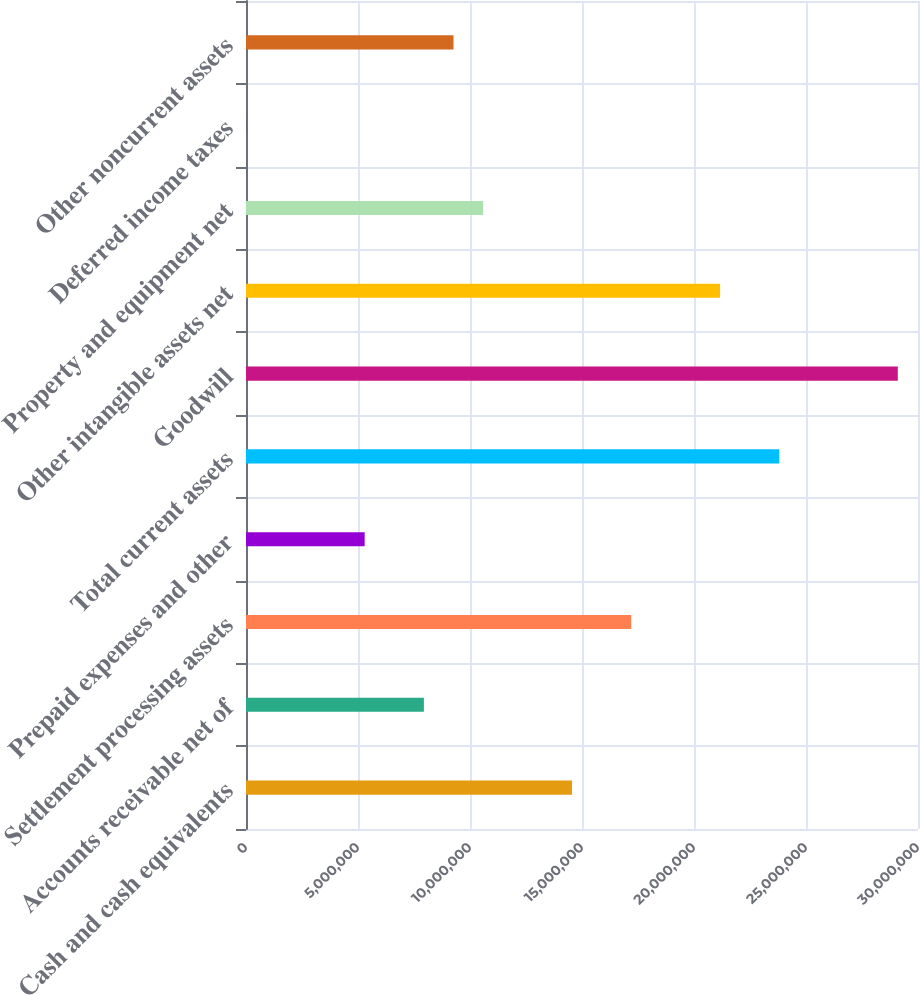Convert chart to OTSL. <chart><loc_0><loc_0><loc_500><loc_500><bar_chart><fcel>Cash and cash equivalents<fcel>Accounts receivable net of<fcel>Settlement processing assets<fcel>Prepaid expenses and other<fcel>Total current assets<fcel>Goodwill<fcel>Other intangible assets net<fcel>Property and equipment net<fcel>Deferred income taxes<fcel>Other noncurrent assets<nl><fcel>1.4553e+07<fcel>7.94172e+06<fcel>1.71976e+07<fcel>5.29719e+06<fcel>2.38089e+07<fcel>2.90979e+07<fcel>2.11644e+07<fcel>1.05862e+07<fcel>8128<fcel>9.26398e+06<nl></chart> 